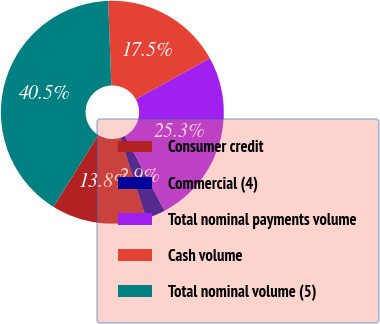Convert chart. <chart><loc_0><loc_0><loc_500><loc_500><pie_chart><fcel>Consumer credit<fcel>Commercial (4)<fcel>Total nominal payments volume<fcel>Cash volume<fcel>Total nominal volume (5)<nl><fcel>13.77%<fcel>2.86%<fcel>25.29%<fcel>17.54%<fcel>40.54%<nl></chart> 